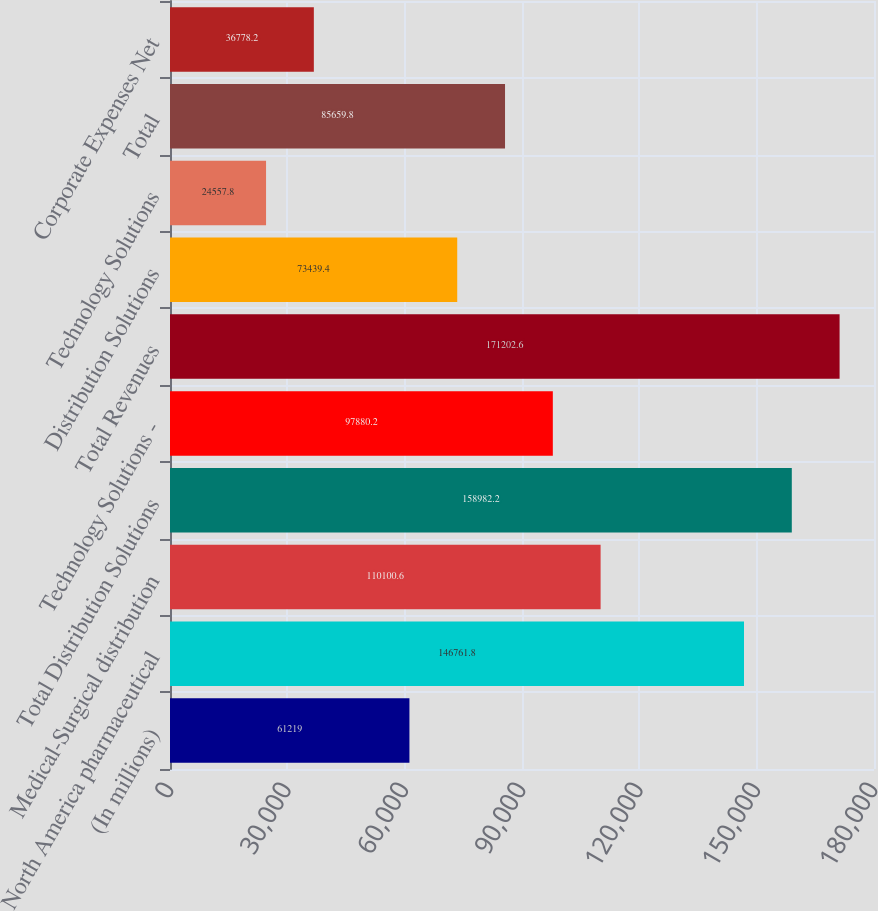<chart> <loc_0><loc_0><loc_500><loc_500><bar_chart><fcel>(In millions)<fcel>North America pharmaceutical<fcel>Medical-Surgical distribution<fcel>Total Distribution Solutions<fcel>Technology Solutions -<fcel>Total Revenues<fcel>Distribution Solutions<fcel>Technology Solutions<fcel>Total<fcel>Corporate Expenses Net<nl><fcel>61219<fcel>146762<fcel>110101<fcel>158982<fcel>97880.2<fcel>171203<fcel>73439.4<fcel>24557.8<fcel>85659.8<fcel>36778.2<nl></chart> 